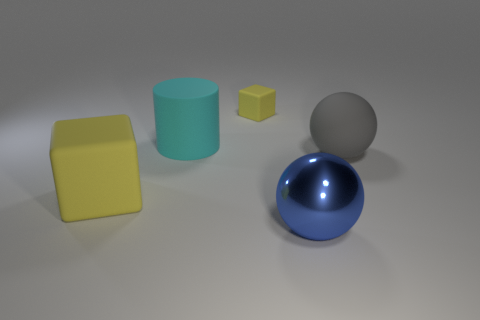Is the color of the tiny rubber block the same as the ball on the right side of the large shiny sphere?
Ensure brevity in your answer.  No. The shiny object is what color?
Your answer should be compact. Blue. What shape is the matte thing that is to the right of the large sphere in front of the object that is right of the big blue metal sphere?
Offer a very short reply. Sphere. What number of other things are the same color as the small matte object?
Your answer should be very brief. 1. Is the number of yellow cubes right of the small yellow matte object greater than the number of large matte spheres to the right of the gray object?
Your response must be concise. No. There is a gray ball; are there any blocks on the right side of it?
Ensure brevity in your answer.  No. What is the material of the big thing that is both behind the metallic thing and right of the tiny matte thing?
Keep it short and to the point. Rubber. There is a matte thing that is the same shape as the blue metal object; what color is it?
Make the answer very short. Gray. Is there a large cyan cylinder right of the small cube that is right of the large yellow matte thing?
Give a very brief answer. No. What size is the cyan rubber thing?
Offer a terse response. Large. 